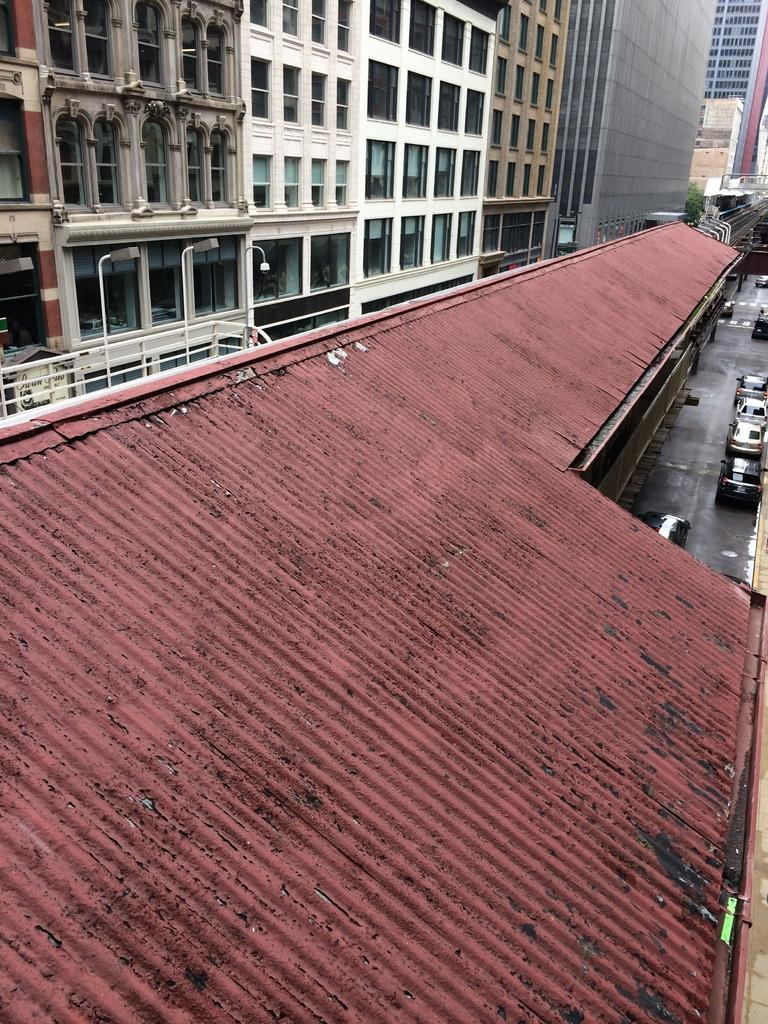What type of material is visible on the roofs in the image? There are roof tiles visible in the image. What can be seen on the road in the image? Cars are parked on the road in the image. What is visible in the distance in the image? There are buildings in the background of the image. What else can be seen in the background of the image? Lights are present in the background of the image. What does the grandmother say about the stem in the image? There is no grandmother or stem present in the image. What type of sound can be heard coming from the cars in the image? The image does not provide any information about sounds, so it cannot be determined what sounds might be heard. 